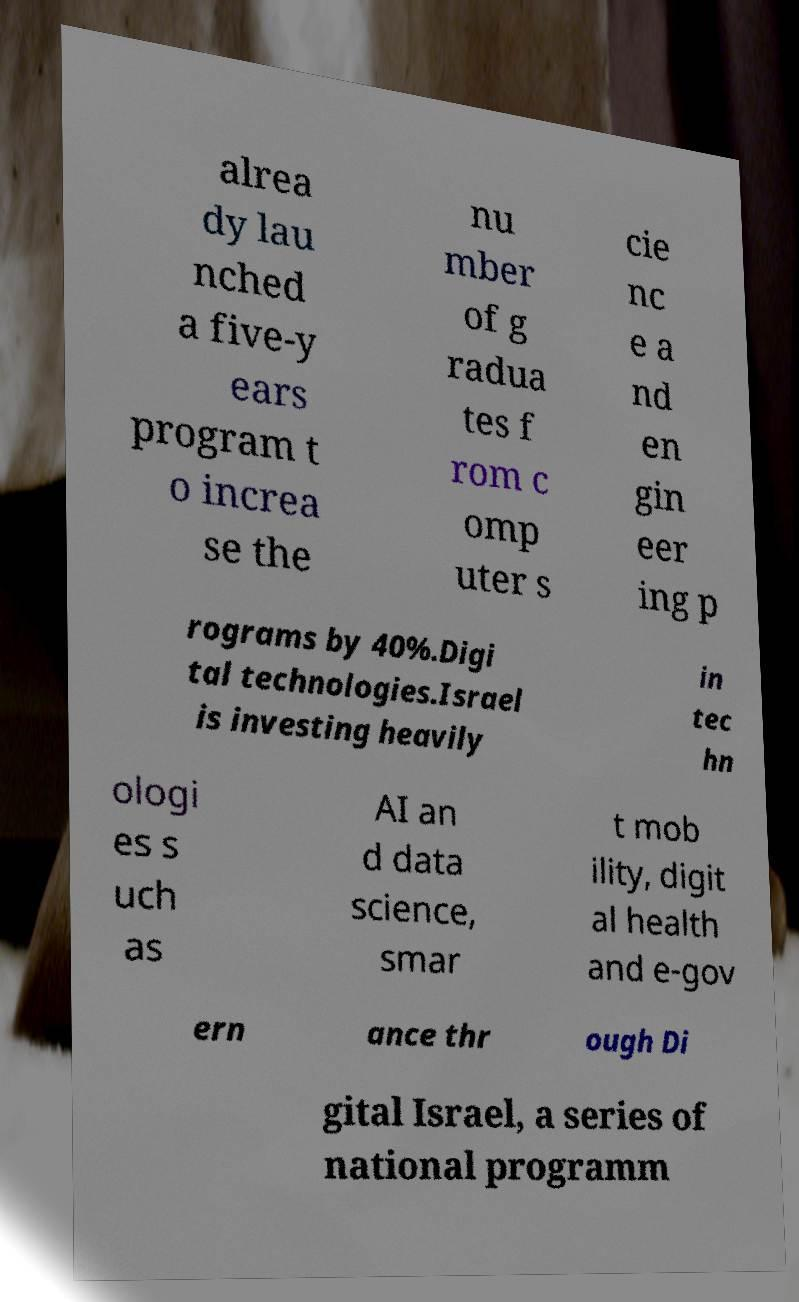Please identify and transcribe the text found in this image. alrea dy lau nched a five-y ears program t o increa se the nu mber of g radua tes f rom c omp uter s cie nc e a nd en gin eer ing p rograms by 40%.Digi tal technologies.Israel is investing heavily in tec hn ologi es s uch as AI an d data science, smar t mob ility, digit al health and e-gov ern ance thr ough Di gital Israel, a series of national programm 